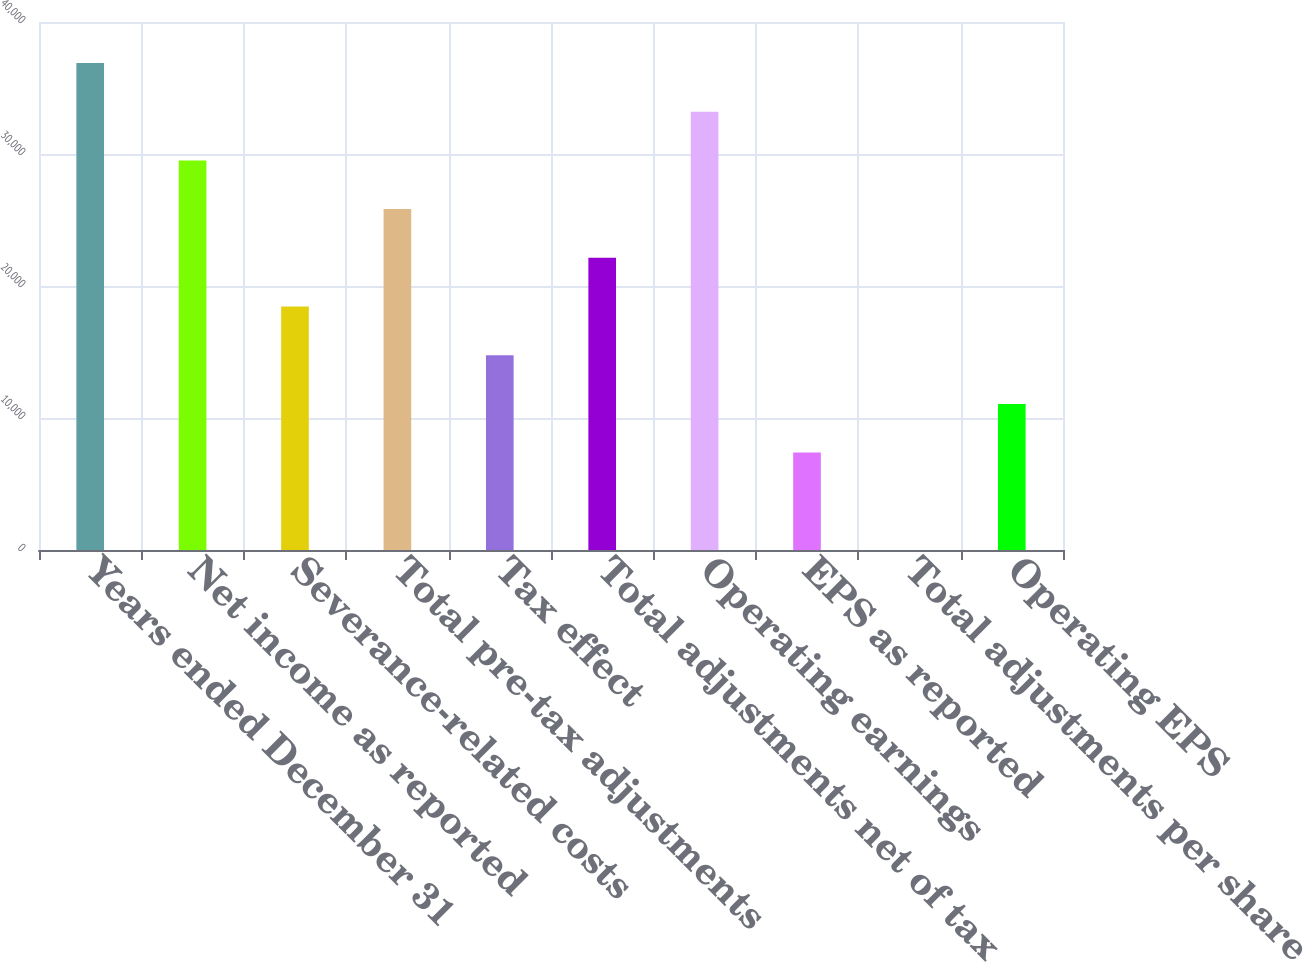Convert chart. <chart><loc_0><loc_0><loc_500><loc_500><bar_chart><fcel>Years ended December 31<fcel>Net income as reported<fcel>Severance-related costs<fcel>Total pre-tax adjustments<fcel>Tax effect<fcel>Total adjustments net of tax<fcel>Operating earnings<fcel>EPS as reported<fcel>Total adjustments per share<fcel>Operating EPS<nl><fcel>36894<fcel>29515.2<fcel>18447<fcel>25825.8<fcel>14757.6<fcel>22136.4<fcel>33204.6<fcel>7378.81<fcel>0.01<fcel>11068.2<nl></chart> 